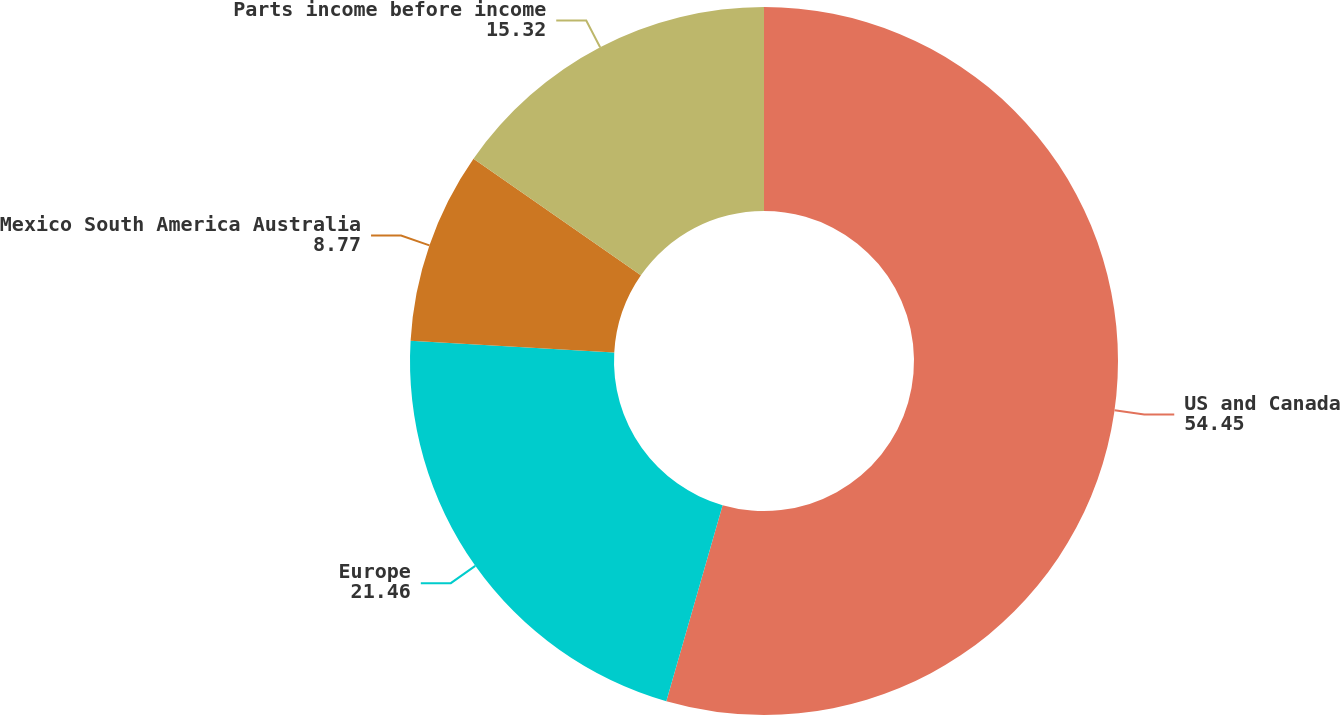<chart> <loc_0><loc_0><loc_500><loc_500><pie_chart><fcel>US and Canada<fcel>Europe<fcel>Mexico South America Australia<fcel>Parts income before income<nl><fcel>54.45%<fcel>21.46%<fcel>8.77%<fcel>15.32%<nl></chart> 